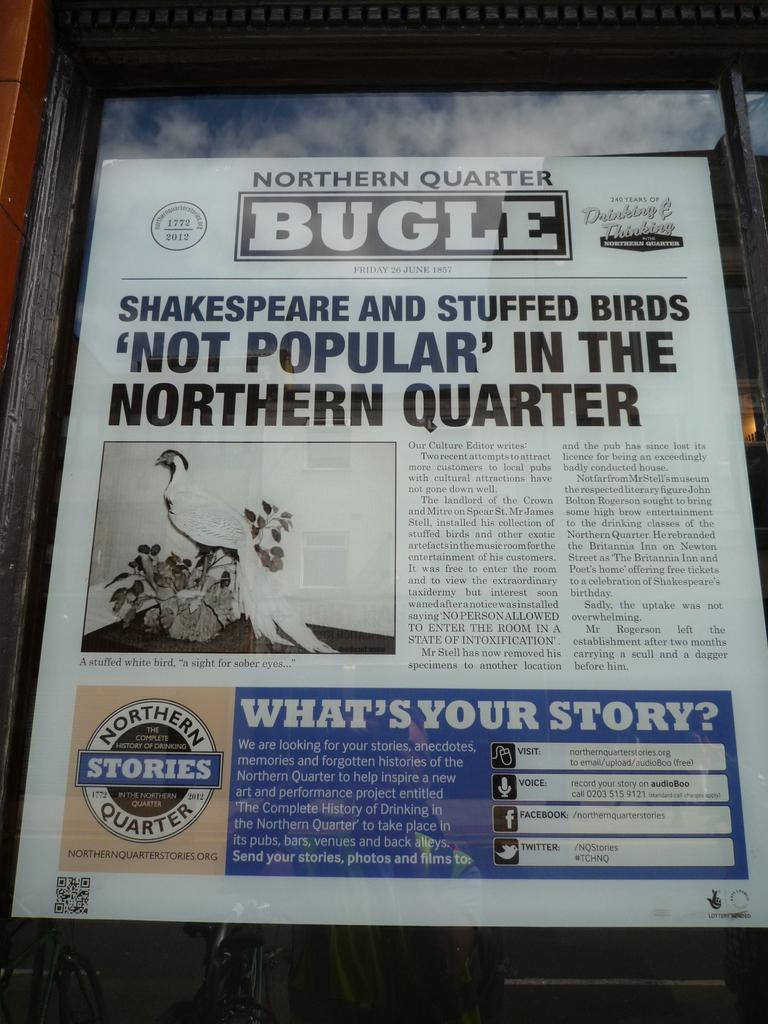<image>
Relay a brief, clear account of the picture shown. A copy of the Northern Quarter Bugle with a bird on the front. 